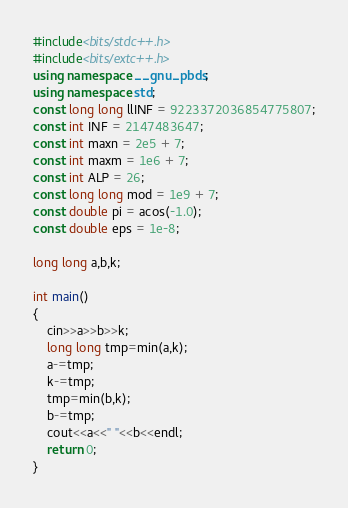<code> <loc_0><loc_0><loc_500><loc_500><_C++_>#include<bits/stdc++.h>
#include<bits/extc++.h>
using namespace __gnu_pbds;
using namespace std;
const long long llINF = 9223372036854775807;
const int INF = 2147483647;
const int maxn = 2e5 + 7;
const int maxm = 1e6 + 7;
const int ALP = 26;
const long long mod = 1e9 + 7;
const double pi = acos(-1.0);
const double eps = 1e-8;

long long a,b,k;

int main()
{
	cin>>a>>b>>k;
	long long tmp=min(a,k);
	a-=tmp;
	k-=tmp;
	tmp=min(b,k);
	b-=tmp;
	cout<<a<<" "<<b<<endl;
	return 0;
}
</code> 